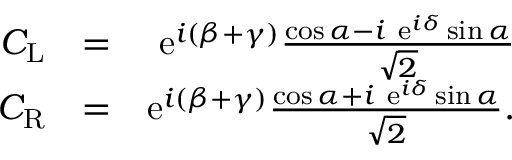<formula> <loc_0><loc_0><loc_500><loc_500>\begin{array} { r l r } { C _ { L } } & { = } & { e ^ { i ( \beta + \gamma ) } \frac { \cos \alpha - i \ e ^ { i \delta } \sin \alpha } { \sqrt { 2 } } } \\ { C _ { R } } & { = } & { e ^ { i ( \beta + \gamma ) } \frac { \cos \alpha + i \ e ^ { i \delta } \sin \alpha } { \sqrt { 2 } } . } \end{array}</formula> 